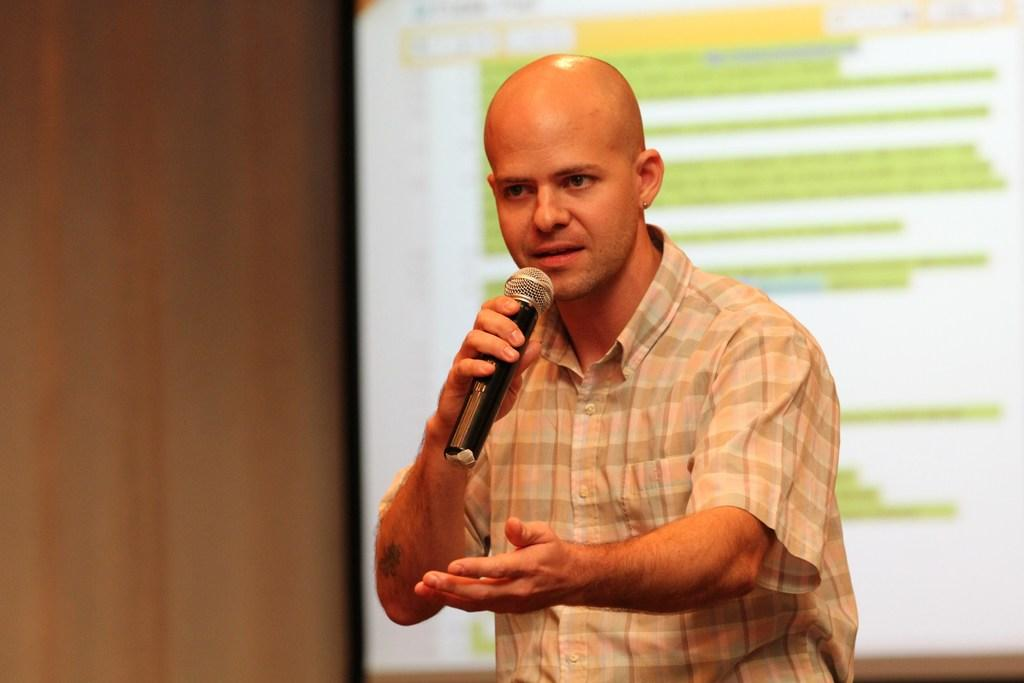What is the person in the image doing? The person is holding a microphone. What is the person wearing in the image? The person is wearing a shirt. What can be seen in the background of the image? There is a screen in the background of the image. What is written on the screen? The screen has some text on it. Can you tell me how many basketballs are visible on the screen in the image? There are no basketballs visible on the screen in the image. What type of zephyr is blowing the person's hair in the image? There is no zephyr present in the image, and the person's hair is not being blown by any wind. 